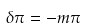<formula> <loc_0><loc_0><loc_500><loc_500>\delta \pi = - m \pi</formula> 